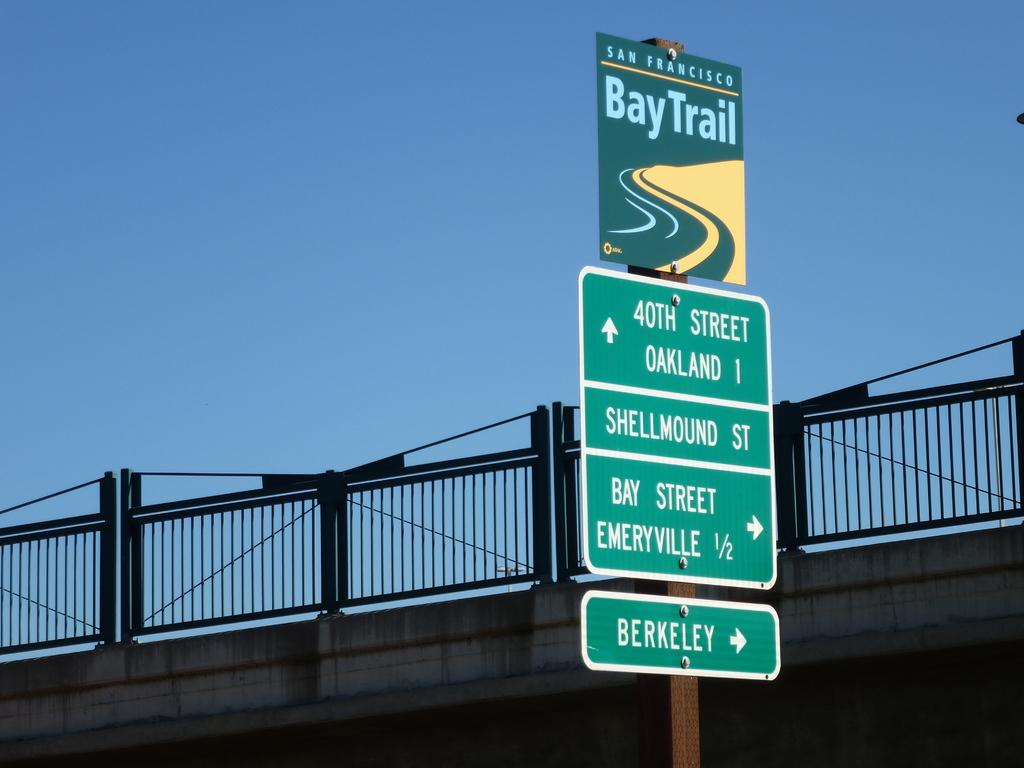Provide a one-sentence caption for the provided image. The Bay Trail sign in San Francisco says Bay Street and Berkeley are to the right and 40th Street is ahead. 